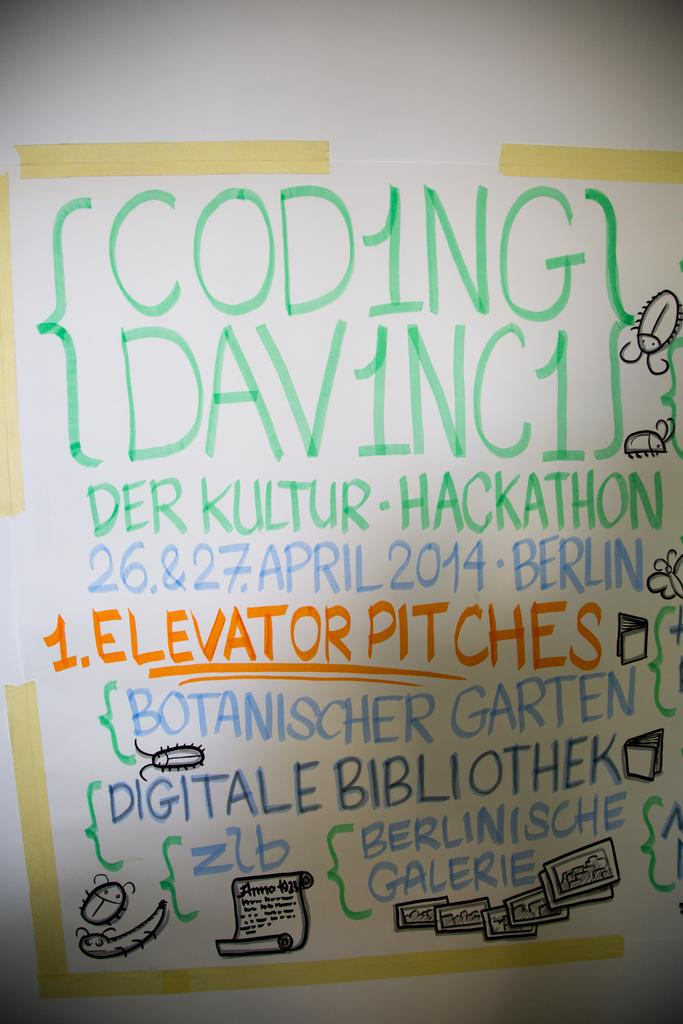<image>
Summarize the visual content of the image. Coding and elevator pitches are being advertised on a multi colored board. 